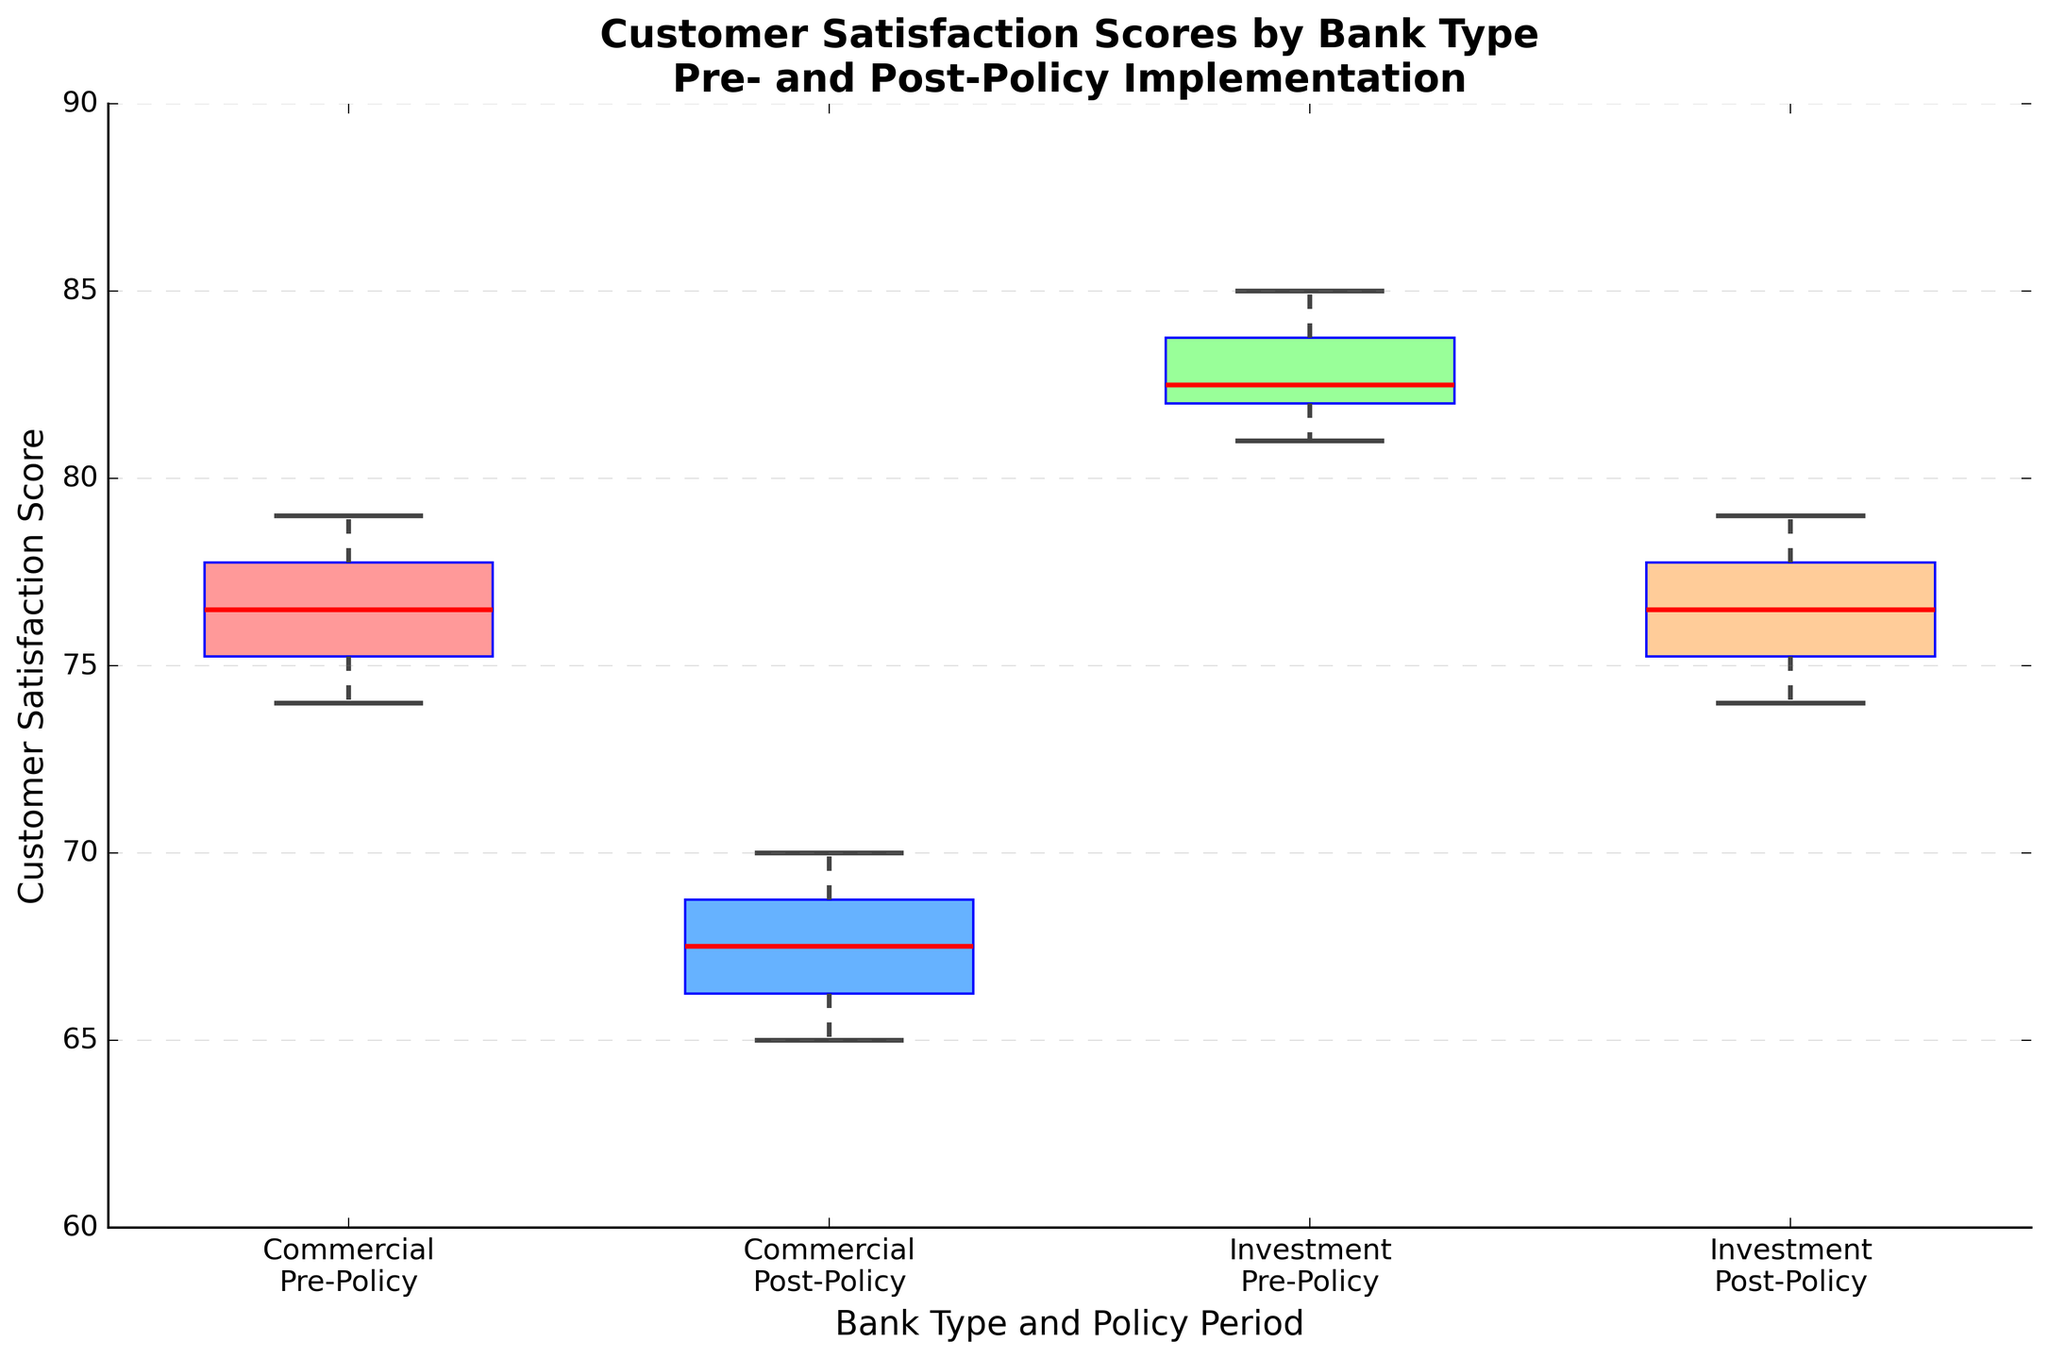What's the title of the plot? The title of the plot is positioned at the top of the figure. It is styled in bold and large font.
Answer: Customer Satisfaction Scores by Bank Type Pre- and Post-Policy Implementation What do the axes represent? The x-axis and y-axis are labeled to indicate their respective measures. The x-axis refers to different bank types and policy periods, while the y-axis refers to the customer satisfaction scores.
Answer: The x-axis represents 'Bank Type and Policy Period', and the y-axis represents 'Customer Satisfaction Score' What is the median satisfaction score for Commercial banks in the Pre-Policy period? The median in a box plot is represented by a red line within the box. For Commercial banks in the Pre-Policy period, this line appears near the 76 mark on the y-axis.
Answer: 76 What is the change in median customer satisfaction for Commercial banks from Pre- to Post-Policy? The median satisfaction score for Commercial banks in the Pre-Policy period is 76, and in the Post-Policy period, it declines to around 67. The change is the difference between these two values.
Answer: -9 Which bank type and period have the highest median customer satisfaction score? By comparing the red median lines across all four groups, it's clear that the median is highest in the Investment banks Pre-Policy group, just above 82.
Answer: Investment Pre-Policy Which bank type shows a greater decline in customer satisfaction median scores after the policy implementation? To determine which bank type shows a greater decline, compare the median scores before and after the policy for both bank types. The Commercial banks show a decline of 9 (76 - 67) while Investment banks show a decline of 5 (82 - 77).
Answer: Commercial How does the spread (interquartile range) of satisfaction scores change for Investment banks from Pre- to Post-Policy? The interquartile range (IQR) is the length of the box in the box plot. For Investment banks, the IQR appears slightly narrower post-policy compared to pre-policy, indicating a reduction in score variability.
Answer: It decreases Are there any outliers in the satisfaction scores for Investment banks Post-Policy? Outliers in a box plot are shown as points outside the whiskers. For Investment banks Post-Policy, no points lie outside the whiskers, indicating no outliers.
Answer: No What is the general trend in customer satisfaction scores after policy implementation? By comparing the positions of the boxes and medians pre- and post-policy for both bank types, it's evident that there is a general downward trend in customer satisfaction scores post-policy.
Answer: Decreasing Which group has more tightly clustered satisfaction scores Post-Policy, Commercial or Investment banks? The spread of the scores can be assessed by the width of the boxes and the length of the whiskers. For Post-Policy periods, Investment banks have a smaller IQR and shorter whiskers compared to Commercial banks, indicating more tightly clustered scores.
Answer: Investment banks 